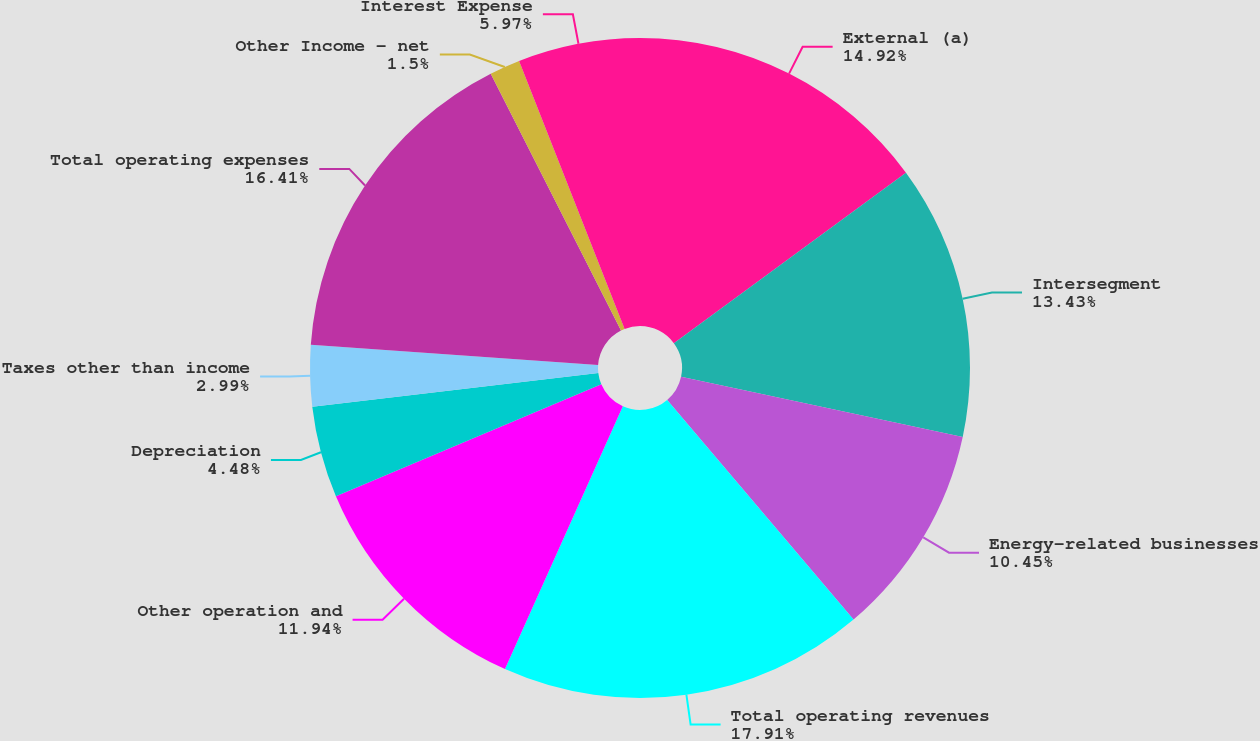<chart> <loc_0><loc_0><loc_500><loc_500><pie_chart><fcel>External (a)<fcel>Intersegment<fcel>Energy-related businesses<fcel>Total operating revenues<fcel>Other operation and<fcel>Depreciation<fcel>Taxes other than income<fcel>Total operating expenses<fcel>Other Income - net<fcel>Interest Expense<nl><fcel>14.92%<fcel>13.43%<fcel>10.45%<fcel>17.91%<fcel>11.94%<fcel>4.48%<fcel>2.99%<fcel>16.41%<fcel>1.5%<fcel>5.97%<nl></chart> 